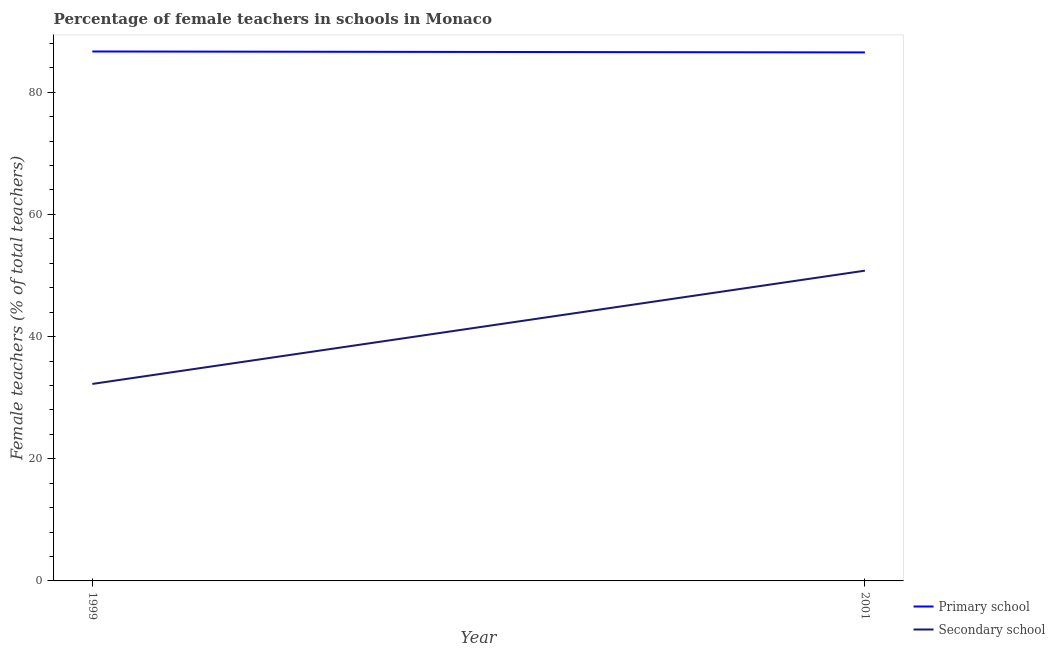How many different coloured lines are there?
Your response must be concise. 2. Is the number of lines equal to the number of legend labels?
Offer a terse response. Yes. What is the percentage of female teachers in primary schools in 1999?
Your answer should be compact. 86.67. Across all years, what is the maximum percentage of female teachers in secondary schools?
Ensure brevity in your answer.  50.79. Across all years, what is the minimum percentage of female teachers in primary schools?
Give a very brief answer. 86.52. In which year was the percentage of female teachers in primary schools maximum?
Keep it short and to the point. 1999. What is the total percentage of female teachers in secondary schools in the graph?
Your answer should be very brief. 83.03. What is the difference between the percentage of female teachers in primary schools in 1999 and that in 2001?
Ensure brevity in your answer.  0.15. What is the difference between the percentage of female teachers in primary schools in 1999 and the percentage of female teachers in secondary schools in 2001?
Your answer should be very brief. 35.88. What is the average percentage of female teachers in primary schools per year?
Offer a very short reply. 86.59. In the year 1999, what is the difference between the percentage of female teachers in secondary schools and percentage of female teachers in primary schools?
Give a very brief answer. -54.42. What is the ratio of the percentage of female teachers in primary schools in 1999 to that in 2001?
Your answer should be compact. 1. Does the percentage of female teachers in primary schools monotonically increase over the years?
Provide a succinct answer. No. Is the percentage of female teachers in primary schools strictly greater than the percentage of female teachers in secondary schools over the years?
Offer a terse response. Yes. Is the percentage of female teachers in primary schools strictly less than the percentage of female teachers in secondary schools over the years?
Provide a short and direct response. No. What is the difference between two consecutive major ticks on the Y-axis?
Make the answer very short. 20. Does the graph contain any zero values?
Offer a terse response. No. How are the legend labels stacked?
Offer a very short reply. Vertical. What is the title of the graph?
Provide a short and direct response. Percentage of female teachers in schools in Monaco. Does "Revenue" appear as one of the legend labels in the graph?
Provide a short and direct response. No. What is the label or title of the Y-axis?
Offer a terse response. Female teachers (% of total teachers). What is the Female teachers (% of total teachers) of Primary school in 1999?
Keep it short and to the point. 86.67. What is the Female teachers (% of total teachers) of Secondary school in 1999?
Your answer should be very brief. 32.25. What is the Female teachers (% of total teachers) of Primary school in 2001?
Provide a succinct answer. 86.52. What is the Female teachers (% of total teachers) in Secondary school in 2001?
Provide a succinct answer. 50.79. Across all years, what is the maximum Female teachers (% of total teachers) in Primary school?
Your answer should be very brief. 86.67. Across all years, what is the maximum Female teachers (% of total teachers) in Secondary school?
Keep it short and to the point. 50.79. Across all years, what is the minimum Female teachers (% of total teachers) in Primary school?
Your answer should be compact. 86.52. Across all years, what is the minimum Female teachers (% of total teachers) of Secondary school?
Offer a very short reply. 32.25. What is the total Female teachers (% of total teachers) in Primary school in the graph?
Ensure brevity in your answer.  173.18. What is the total Female teachers (% of total teachers) in Secondary school in the graph?
Your response must be concise. 83.03. What is the difference between the Female teachers (% of total teachers) in Primary school in 1999 and that in 2001?
Provide a succinct answer. 0.15. What is the difference between the Female teachers (% of total teachers) in Secondary school in 1999 and that in 2001?
Your answer should be very brief. -18.54. What is the difference between the Female teachers (% of total teachers) in Primary school in 1999 and the Female teachers (% of total teachers) in Secondary school in 2001?
Provide a short and direct response. 35.88. What is the average Female teachers (% of total teachers) in Primary school per year?
Ensure brevity in your answer.  86.59. What is the average Female teachers (% of total teachers) in Secondary school per year?
Your answer should be very brief. 41.52. In the year 1999, what is the difference between the Female teachers (% of total teachers) of Primary school and Female teachers (% of total teachers) of Secondary school?
Ensure brevity in your answer.  54.42. In the year 2001, what is the difference between the Female teachers (% of total teachers) in Primary school and Female teachers (% of total teachers) in Secondary school?
Your answer should be compact. 35.73. What is the ratio of the Female teachers (% of total teachers) of Secondary school in 1999 to that in 2001?
Offer a terse response. 0.63. What is the difference between the highest and the second highest Female teachers (% of total teachers) in Primary school?
Your answer should be very brief. 0.15. What is the difference between the highest and the second highest Female teachers (% of total teachers) in Secondary school?
Make the answer very short. 18.54. What is the difference between the highest and the lowest Female teachers (% of total teachers) of Primary school?
Make the answer very short. 0.15. What is the difference between the highest and the lowest Female teachers (% of total teachers) of Secondary school?
Make the answer very short. 18.54. 